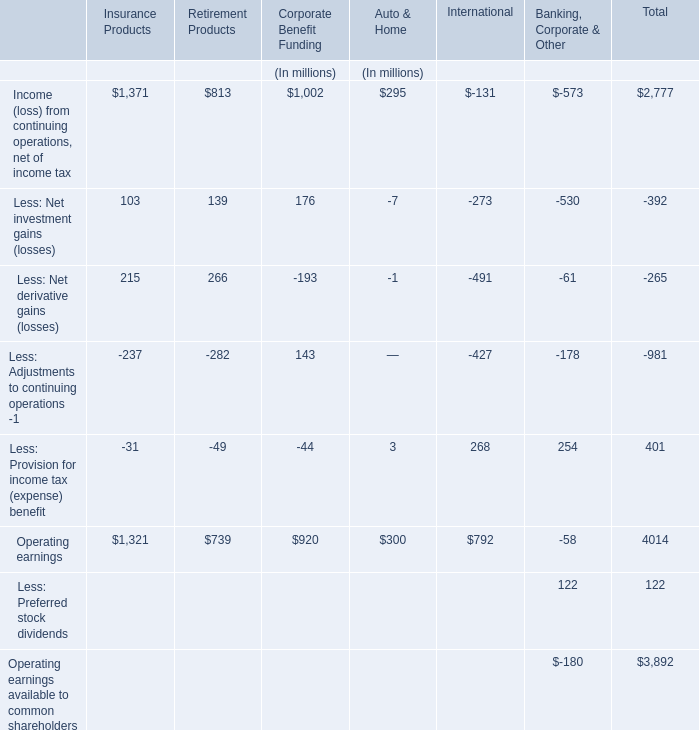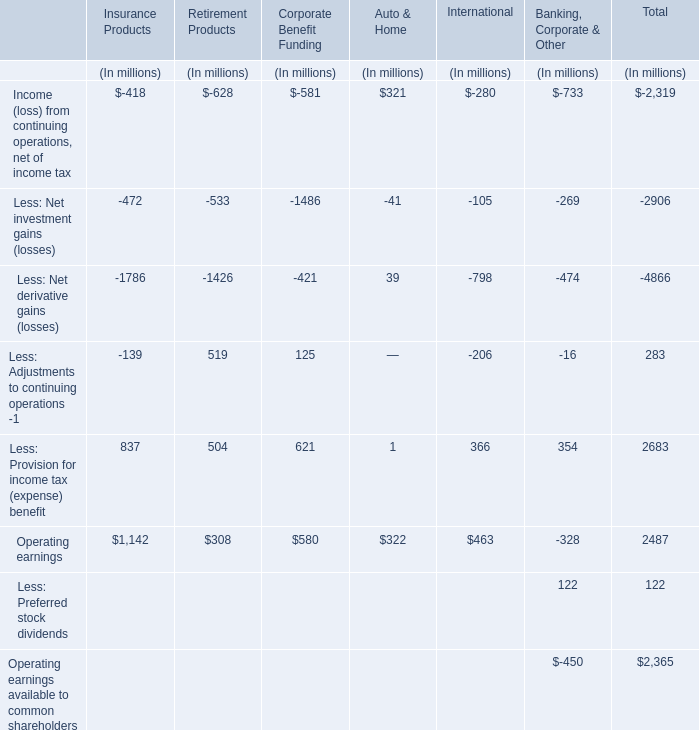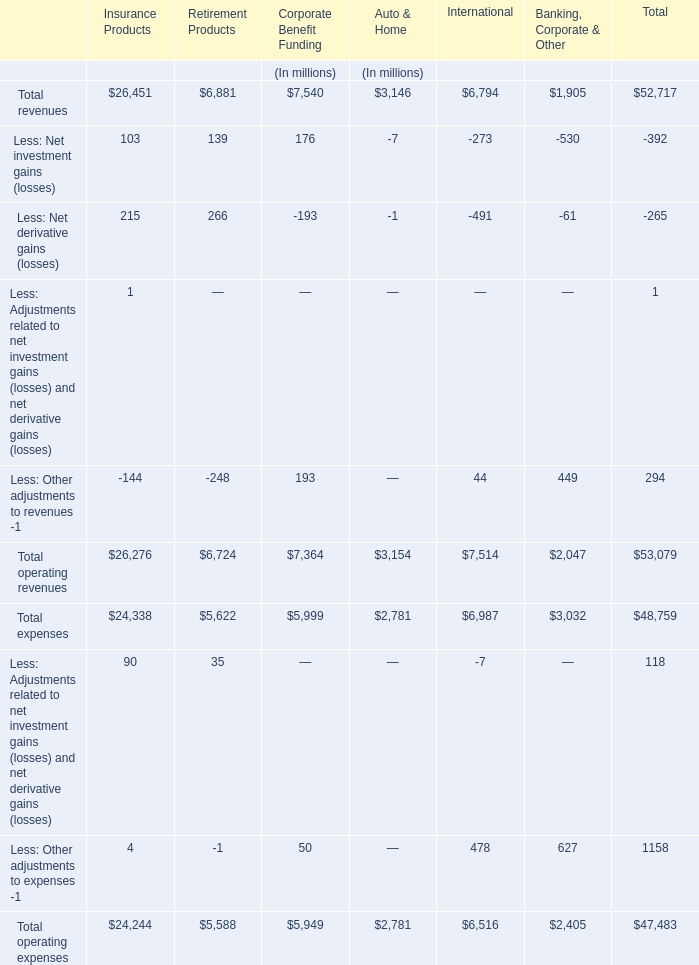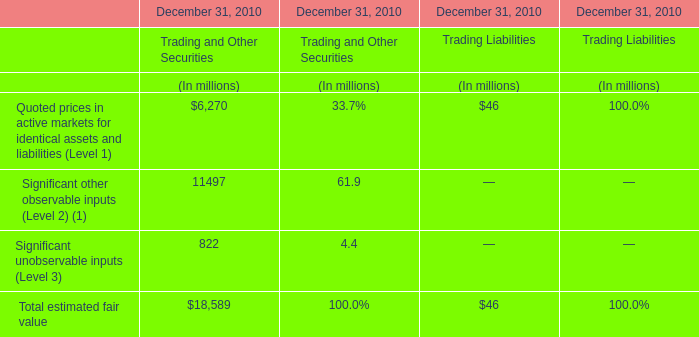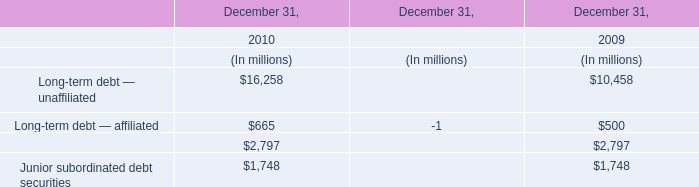What is the percentage of the Operating earnings of Insurance Products in relation to the total Operating earnings? 
Computations: (1142 / 2487)
Answer: 0.45919. 